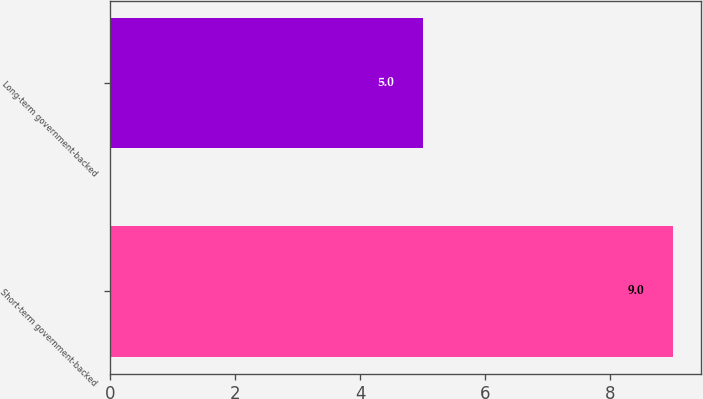Convert chart to OTSL. <chart><loc_0><loc_0><loc_500><loc_500><bar_chart><fcel>Short-term government-backed<fcel>Long-term government-backed<nl><fcel>9<fcel>5<nl></chart> 